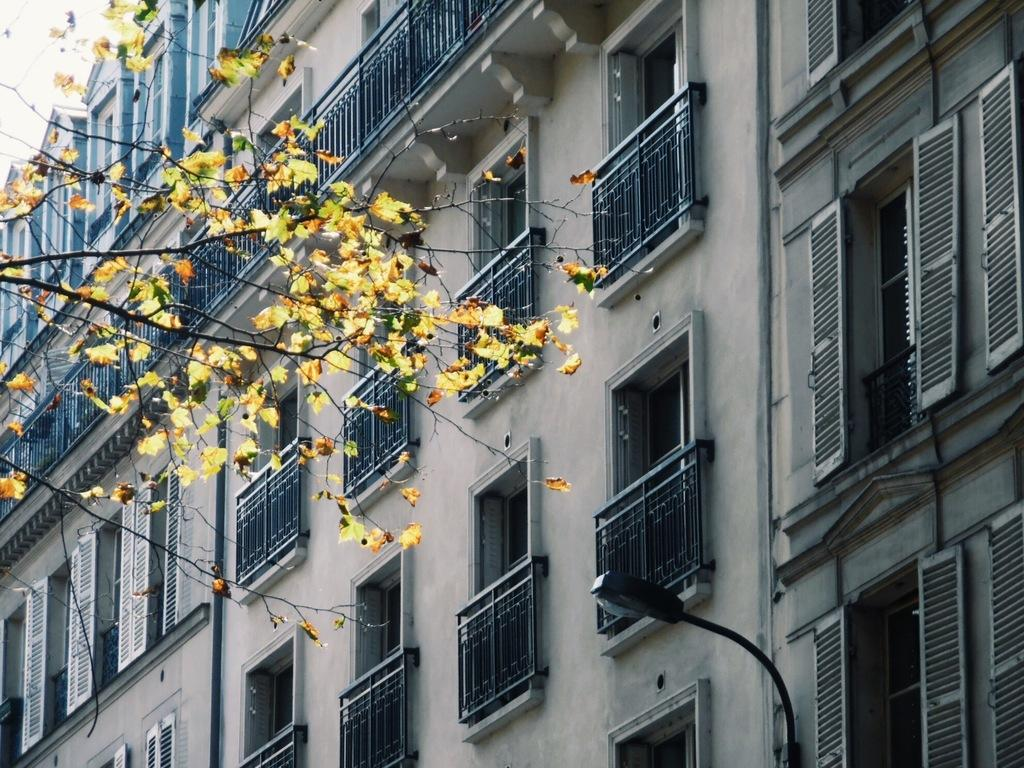What type of natural element is present in the image? There is a tree in the image. What type of man-made structures are present in the image? There are buildings in the image. What type of artificial light source is present in the image? There is a street light in the image. What type of openings are visible in the buildings? There are windows visible in the image. What type of tin can be seen in the aftermath of the storm in the image? There is no tin or storm present in the image. How does the image depict the process of change? The image does not depict a process of change; it shows a tree, buildings, a street light, and windows. 